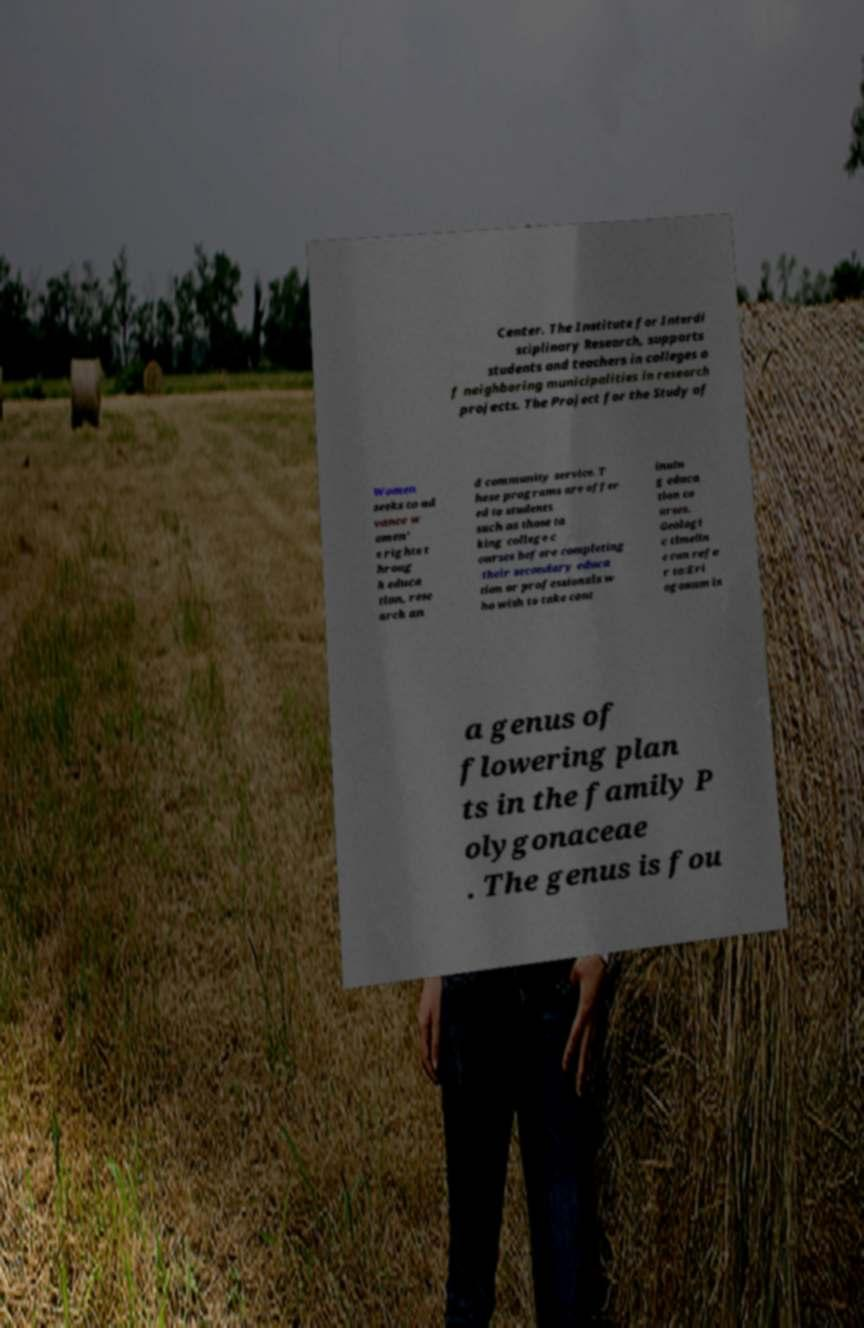Can you read and provide the text displayed in the image?This photo seems to have some interesting text. Can you extract and type it out for me? Center. The Institute for Interdi sciplinary Research, supports students and teachers in colleges o f neighboring municipalities in research projects. The Project for the Study of Women seeks to ad vance w omen' s rights t hroug h educa tion, rese arch an d community service. T hese programs are offer ed to students such as those ta king college c ourses before completing their secondary educa tion or professionals w ho wish to take cont inuin g educa tion co urses. Geologi c timelin e can refe r to:Eri ogonum is a genus of flowering plan ts in the family P olygonaceae . The genus is fou 